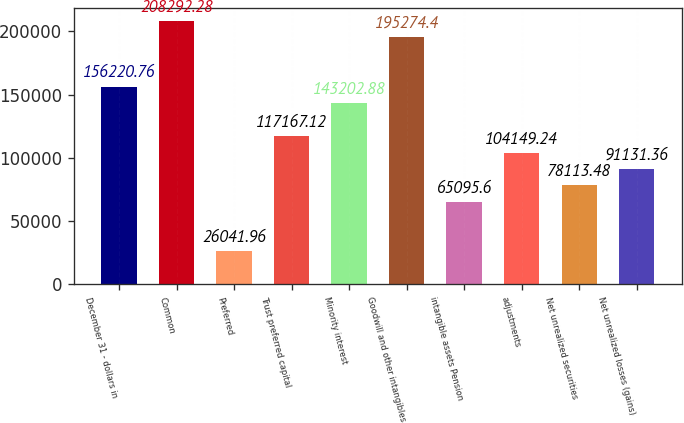<chart> <loc_0><loc_0><loc_500><loc_500><bar_chart><fcel>December 31 - dollars in<fcel>Common<fcel>Preferred<fcel>Trust preferred capital<fcel>Minority interest<fcel>Goodwill and other intangibles<fcel>intangible assets Pension<fcel>adjustments<fcel>Net unrealized securities<fcel>Net unrealized losses (gains)<nl><fcel>156221<fcel>208292<fcel>26042<fcel>117167<fcel>143203<fcel>195274<fcel>65095.6<fcel>104149<fcel>78113.5<fcel>91131.4<nl></chart> 